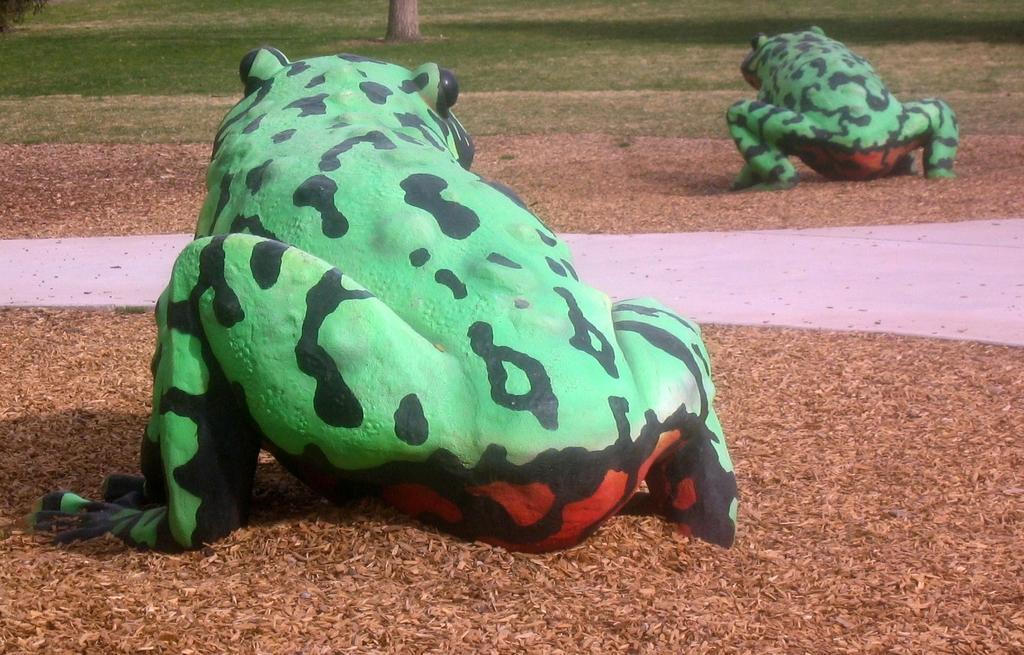Could you give a brief overview of what you see in this image? Here in this picture we can see frogs present on the ground over there and we can also see some part of ground is covered with grass and we can see plants and trees present here and there. 